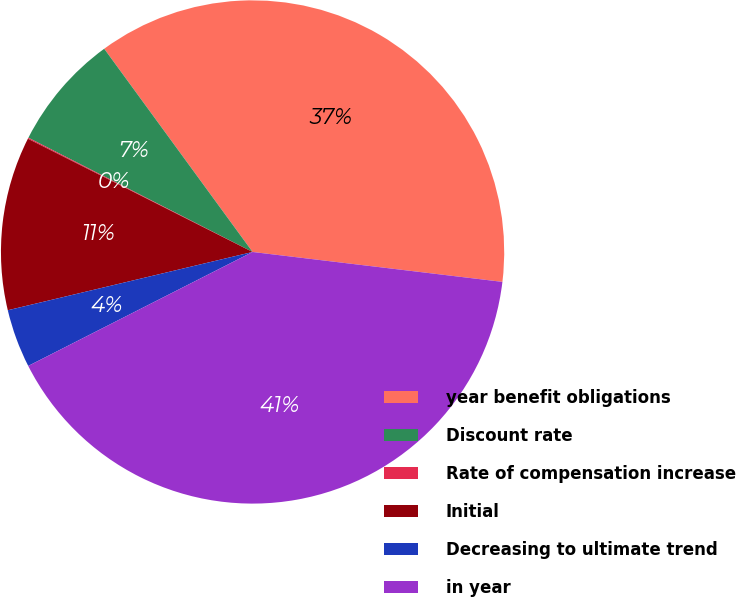Convert chart to OTSL. <chart><loc_0><loc_0><loc_500><loc_500><pie_chart><fcel>year benefit obligations<fcel>Discount rate<fcel>Rate of compensation increase<fcel>Initial<fcel>Decreasing to ultimate trend<fcel>in year<nl><fcel>36.93%<fcel>7.46%<fcel>0.07%<fcel>11.15%<fcel>3.76%<fcel>40.62%<nl></chart> 